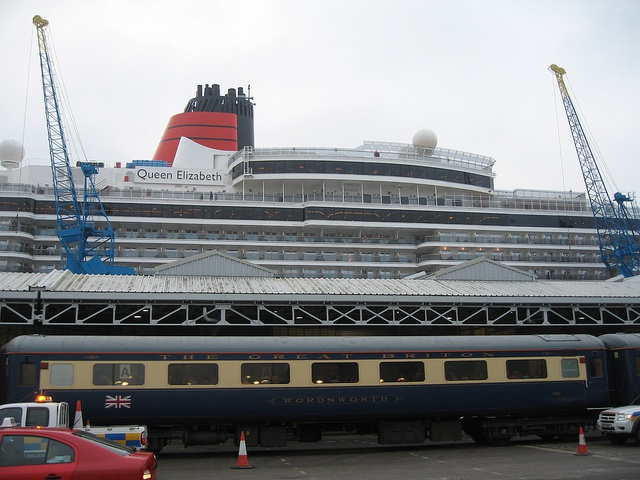Describe the objects in this image and their specific colors. I can see boat in lightgray, gray, darkgray, and black tones, train in lightgray, black, and gray tones, car in lightgray, brown, maroon, and gray tones, truck in lightgray, darkgray, black, gray, and navy tones, and truck in lightgray, black, gray, and darkgray tones in this image. 